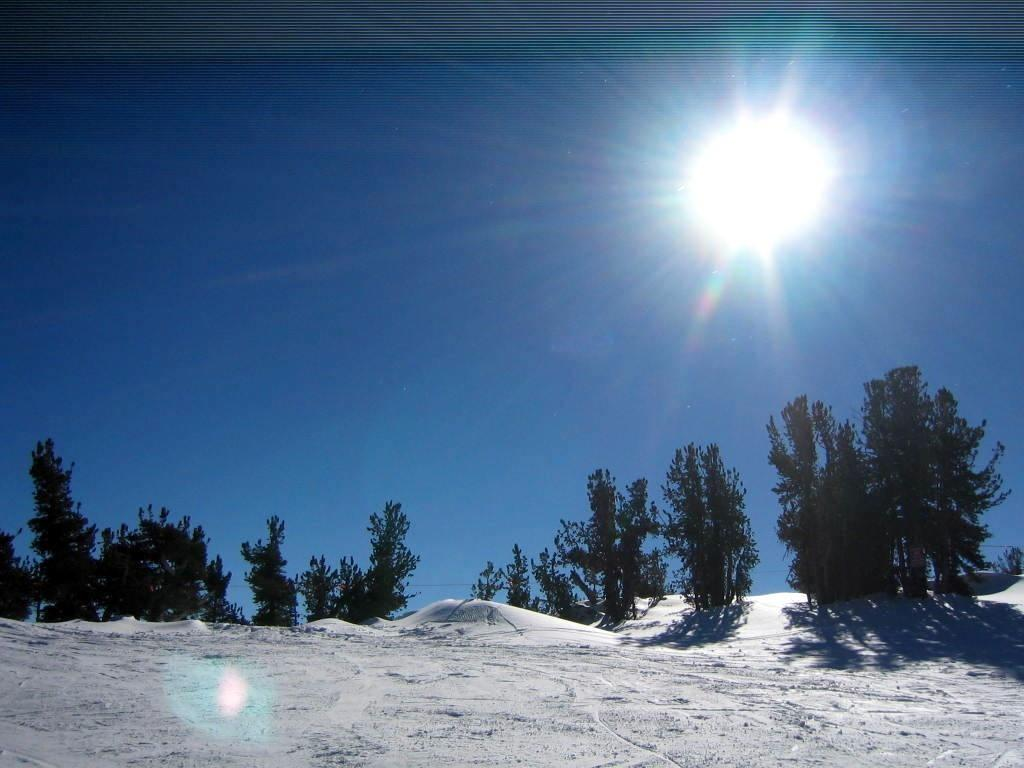What type of natural environment is depicted at the bottom of the image? There is snow at the bottom of the image. What type of vegetation can be seen in the middle of the image? There are green trees in the middle of the image. What is visible in the sky in the image? The sky is visible in the image. Can you describe the celestial body present in the sky? The sun is present in the sky. What type of cream is being poured into the cup in the image? There is no cup or cream present in the image. What type of war is being depicted in the image? There is no war depicted in the image; it features snow, green trees, and the sky. 